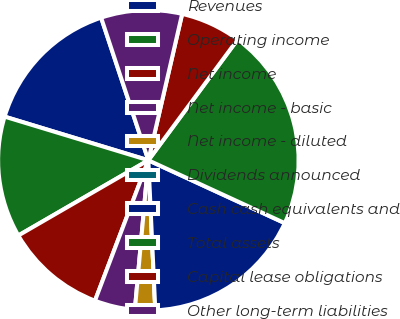Convert chart. <chart><loc_0><loc_0><loc_500><loc_500><pie_chart><fcel>Revenues<fcel>Operating income<fcel>Net income<fcel>Net income - basic<fcel>Net income - diluted<fcel>Dividends announced<fcel>Cash cash equivalents and<fcel>Total assets<fcel>Capital lease obligations<fcel>Other long-term liabilities<nl><fcel>15.22%<fcel>13.04%<fcel>10.87%<fcel>4.35%<fcel>2.17%<fcel>0.0%<fcel>17.39%<fcel>21.74%<fcel>6.52%<fcel>8.7%<nl></chart> 